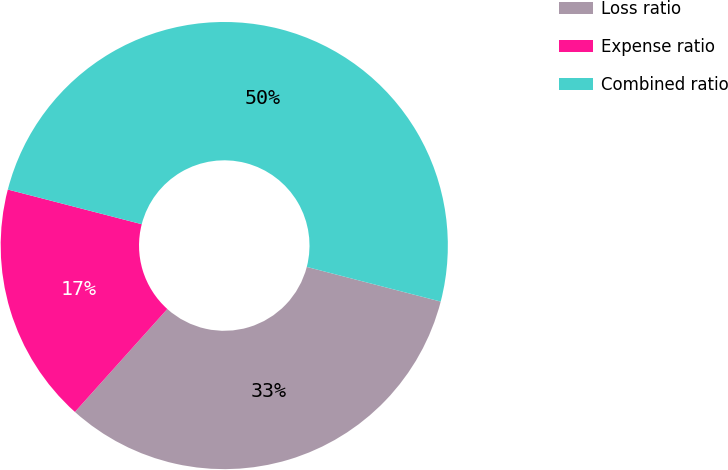<chart> <loc_0><loc_0><loc_500><loc_500><pie_chart><fcel>Loss ratio<fcel>Expense ratio<fcel>Combined ratio<nl><fcel>32.61%<fcel>17.39%<fcel>50.0%<nl></chart> 